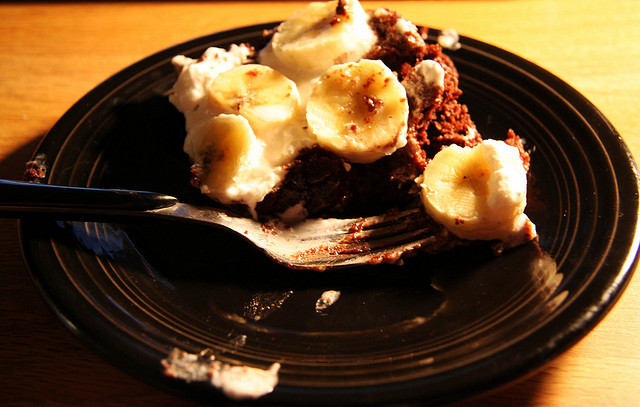What kind of food is depicted in the image? The image shows a delicious slice of chocolate cake topped with banana slices, served on a black plate. 